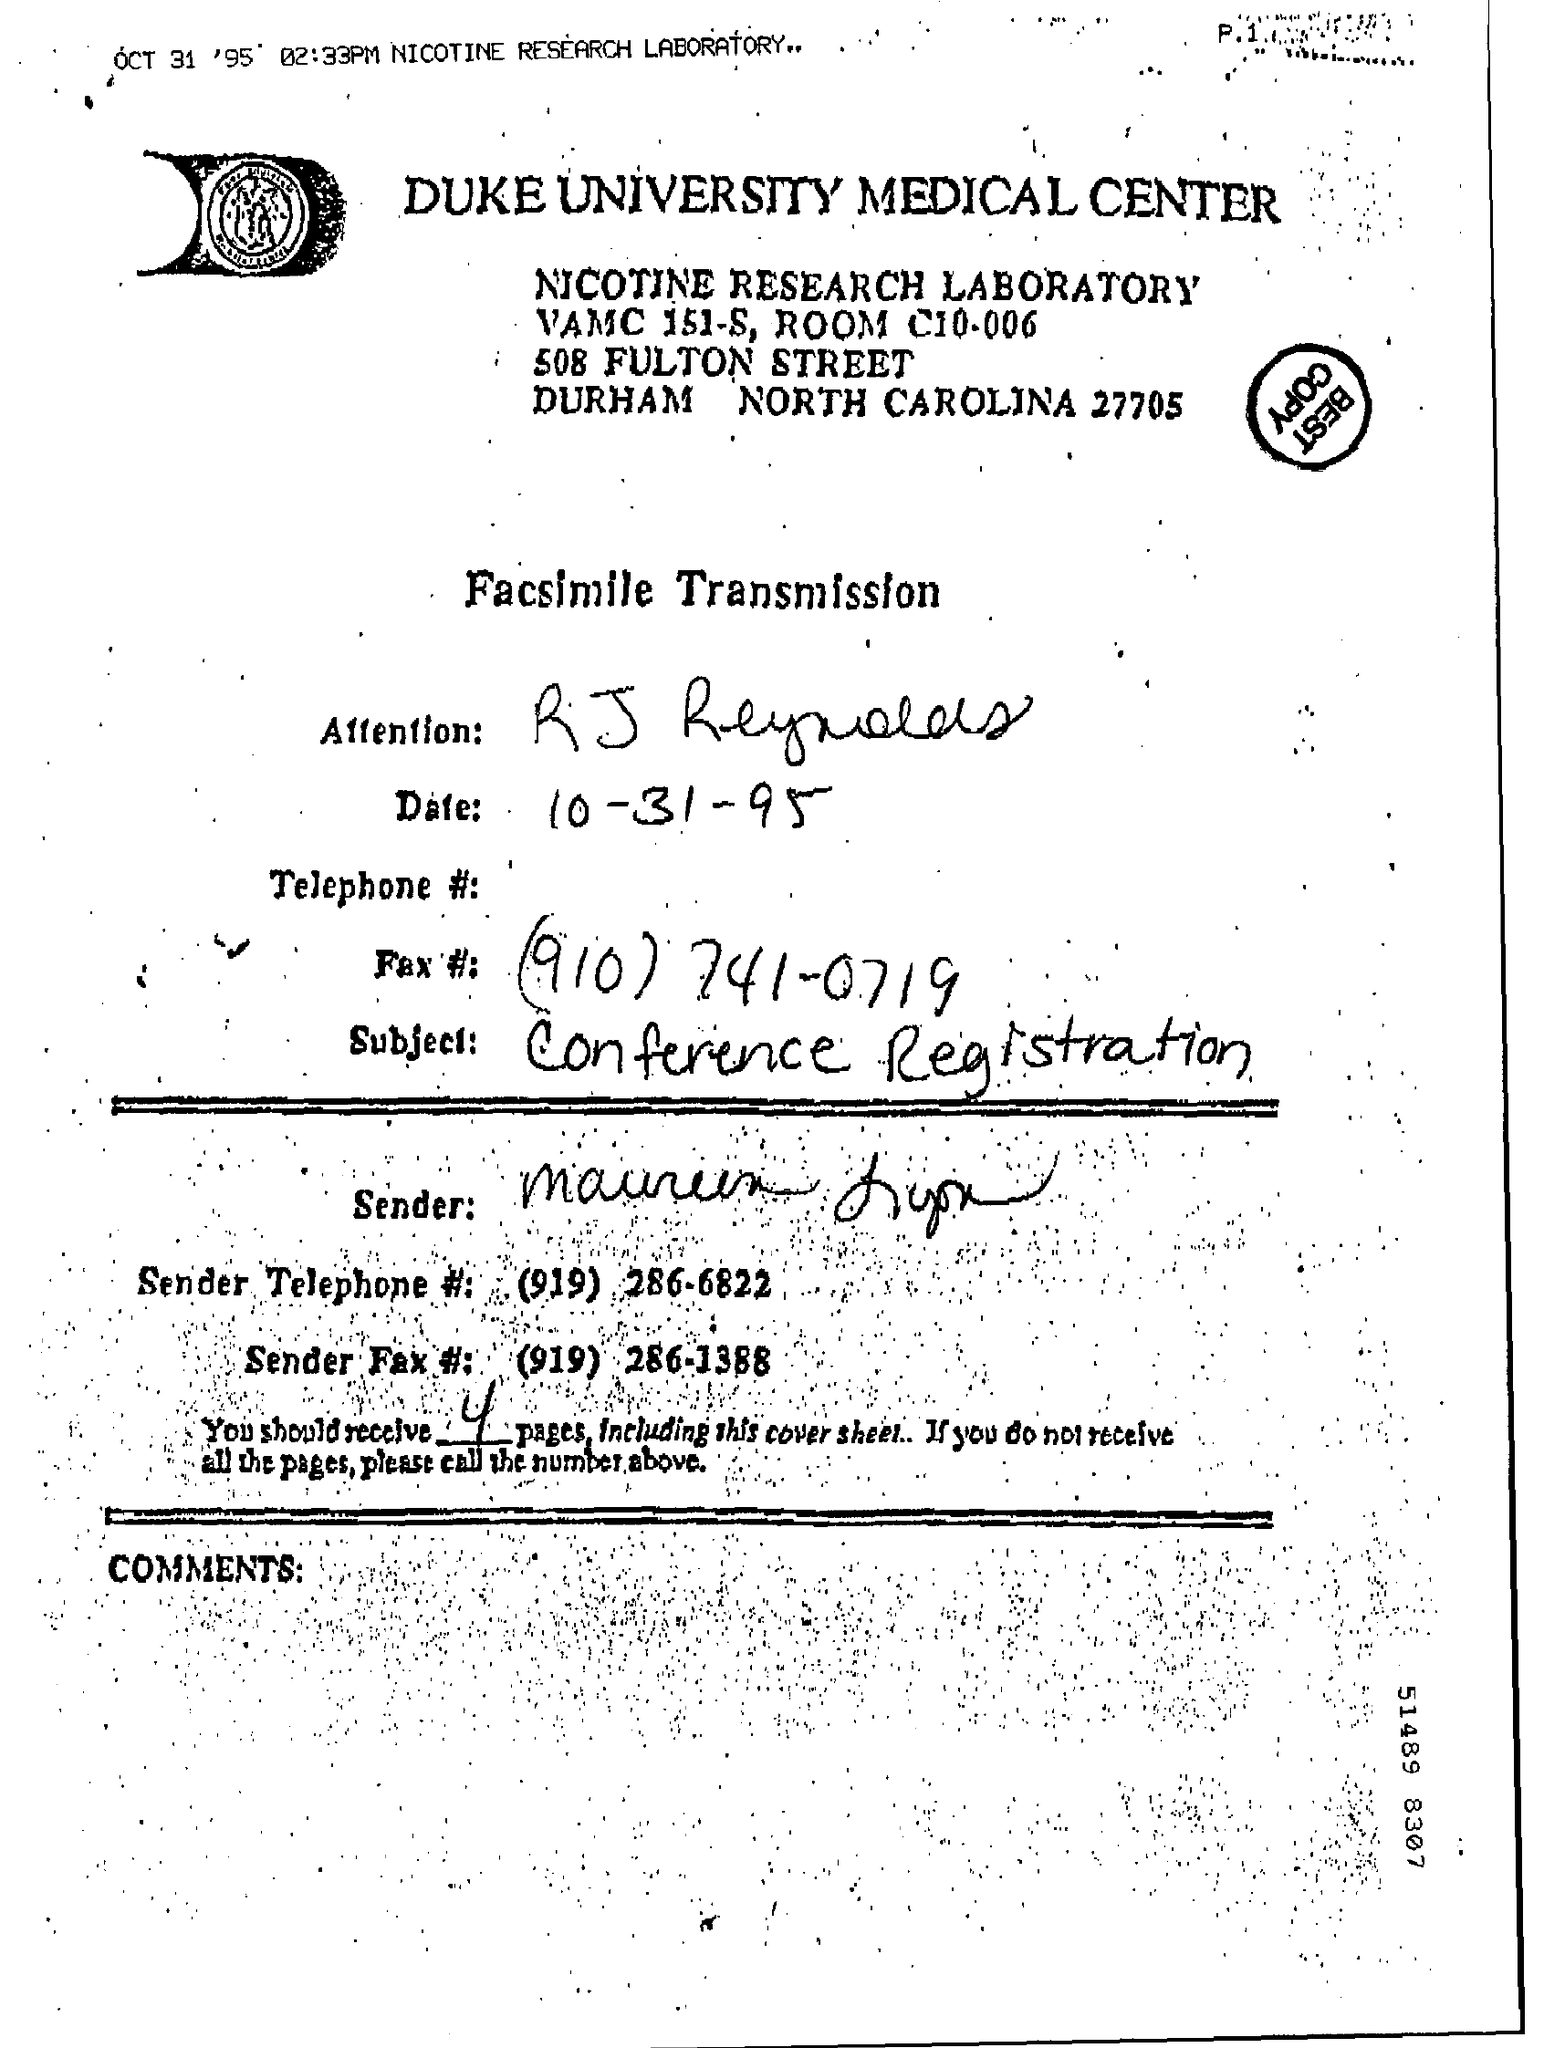What is the 'subject' of the facsimile transmission ?
Ensure brevity in your answer.  Conference registration. What is the facsimile date ?
Provide a short and direct response. OCT 31 '95. How many pages are sent?
Keep it short and to the point. 4. 